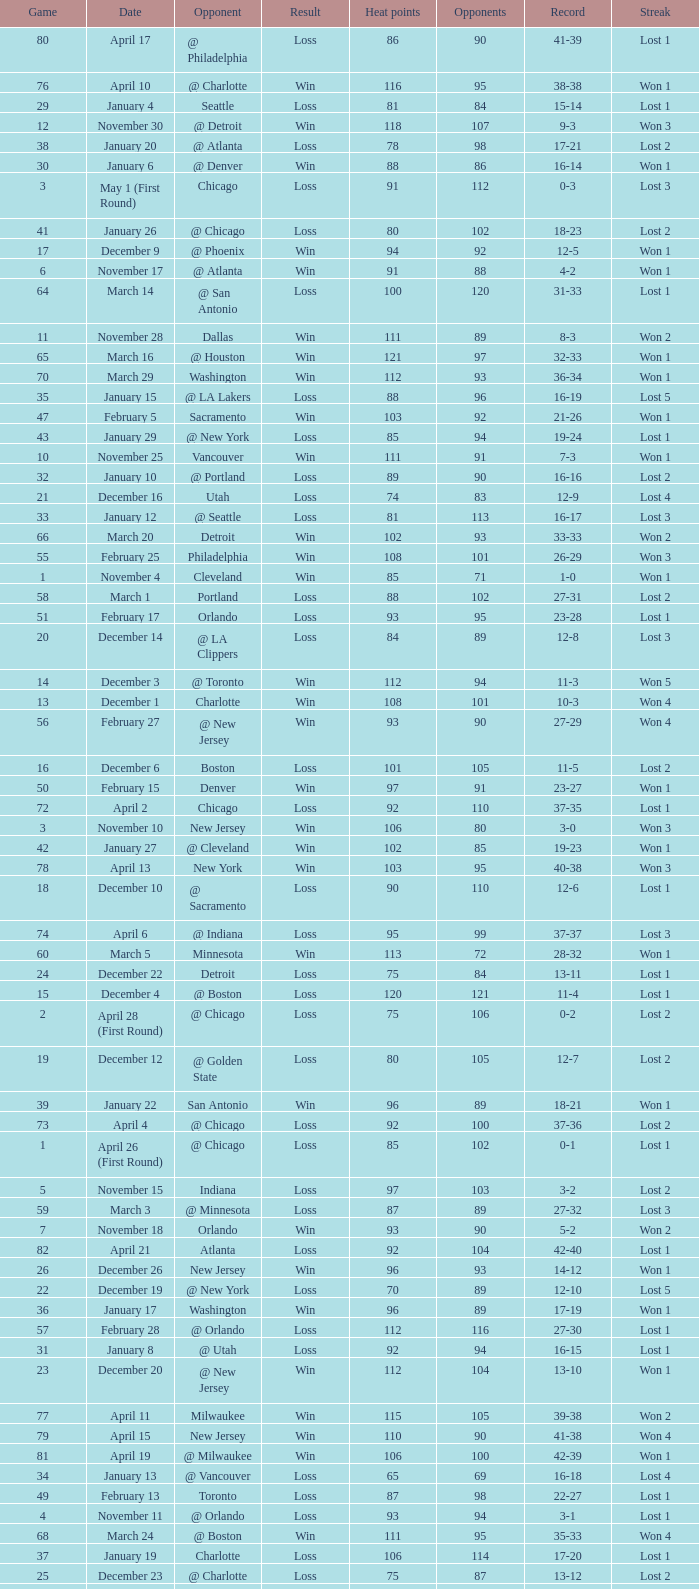What is the highest Game, when Opponents is less than 80, and when Record is "1-0"? 1.0. 